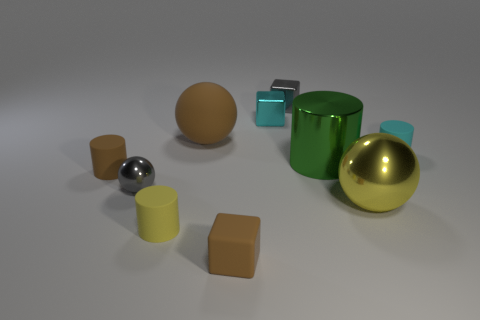Subtract all balls. How many objects are left? 7 Subtract 1 gray cubes. How many objects are left? 9 Subtract all small brown rubber blocks. Subtract all yellow matte things. How many objects are left? 8 Add 6 large rubber objects. How many large rubber objects are left? 7 Add 9 rubber balls. How many rubber balls exist? 10 